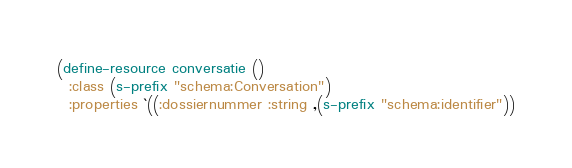Convert code to text. <code><loc_0><loc_0><loc_500><loc_500><_Lisp_>(define-resource conversatie ()
  :class (s-prefix "schema:Conversation")
  :properties `((:dossiernummer :string ,(s-prefix "schema:identifier"))</code> 